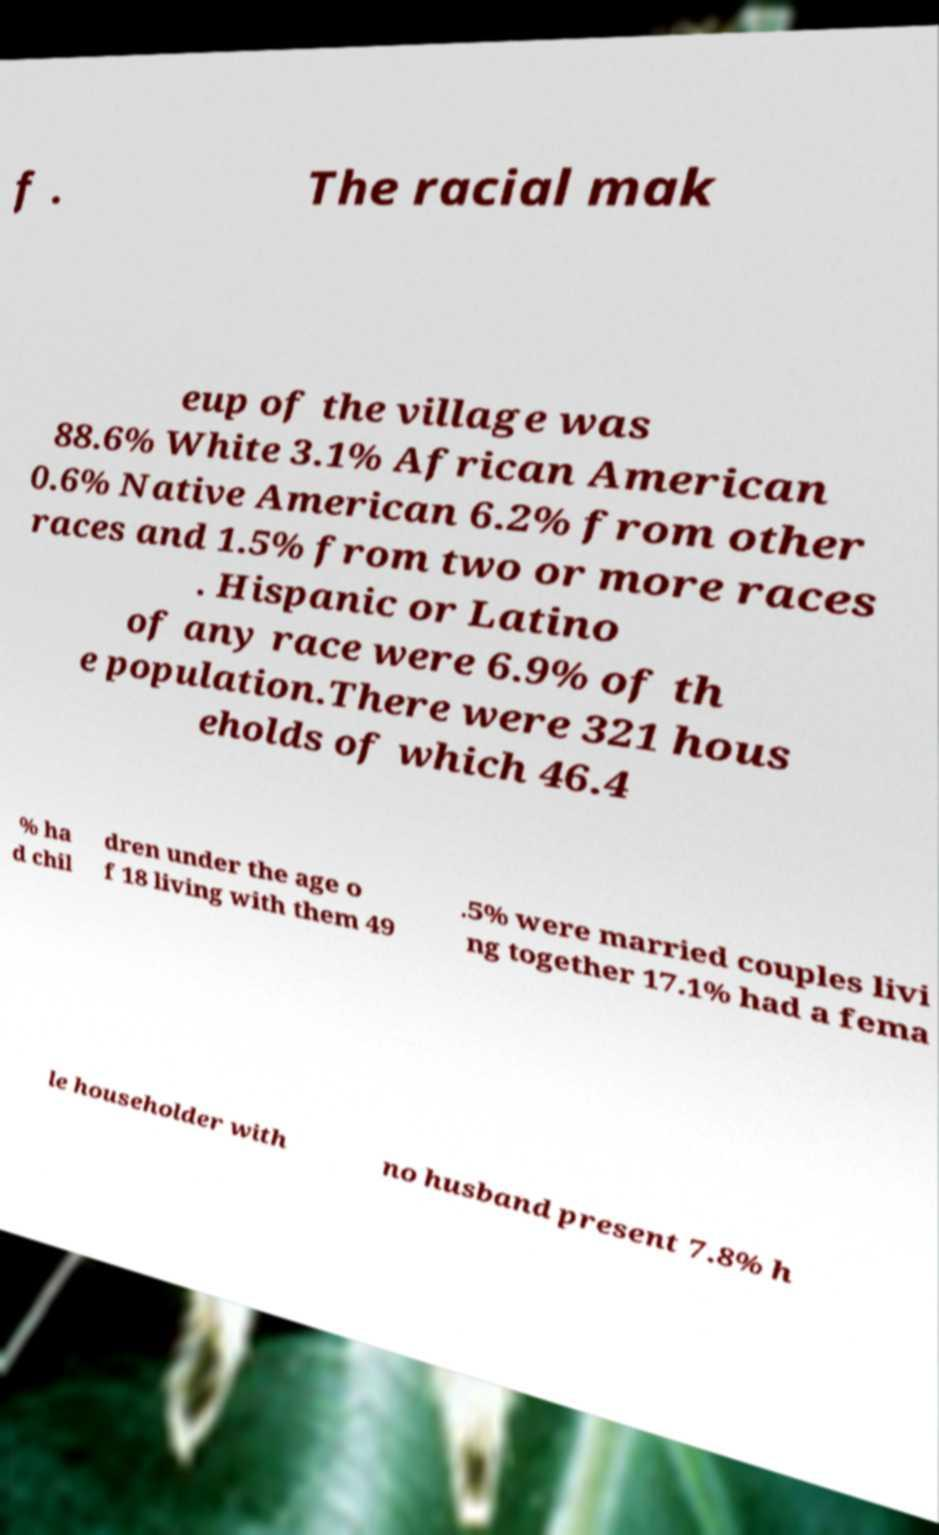Could you extract and type out the text from this image? f . The racial mak eup of the village was 88.6% White 3.1% African American 0.6% Native American 6.2% from other races and 1.5% from two or more races . Hispanic or Latino of any race were 6.9% of th e population.There were 321 hous eholds of which 46.4 % ha d chil dren under the age o f 18 living with them 49 .5% were married couples livi ng together 17.1% had a fema le householder with no husband present 7.8% h 